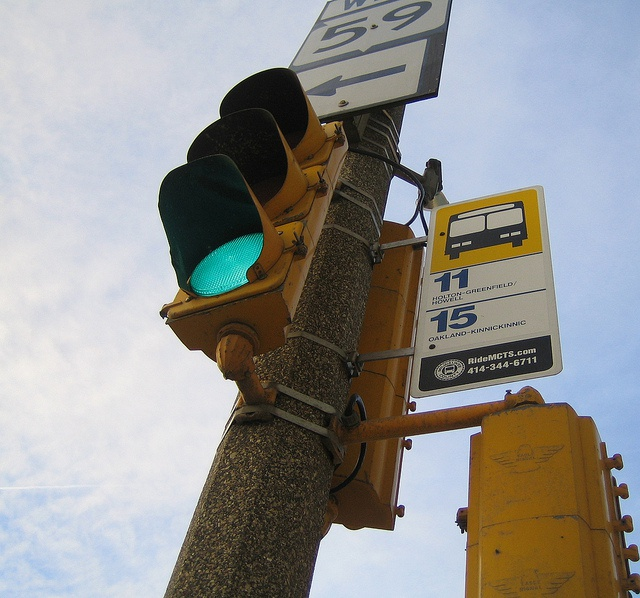Describe the objects in this image and their specific colors. I can see traffic light in lightgray, black, maroon, and teal tones, traffic light in lightgray, olive, maroon, and lightblue tones, and traffic light in lightgray, maroon, black, and gray tones in this image. 